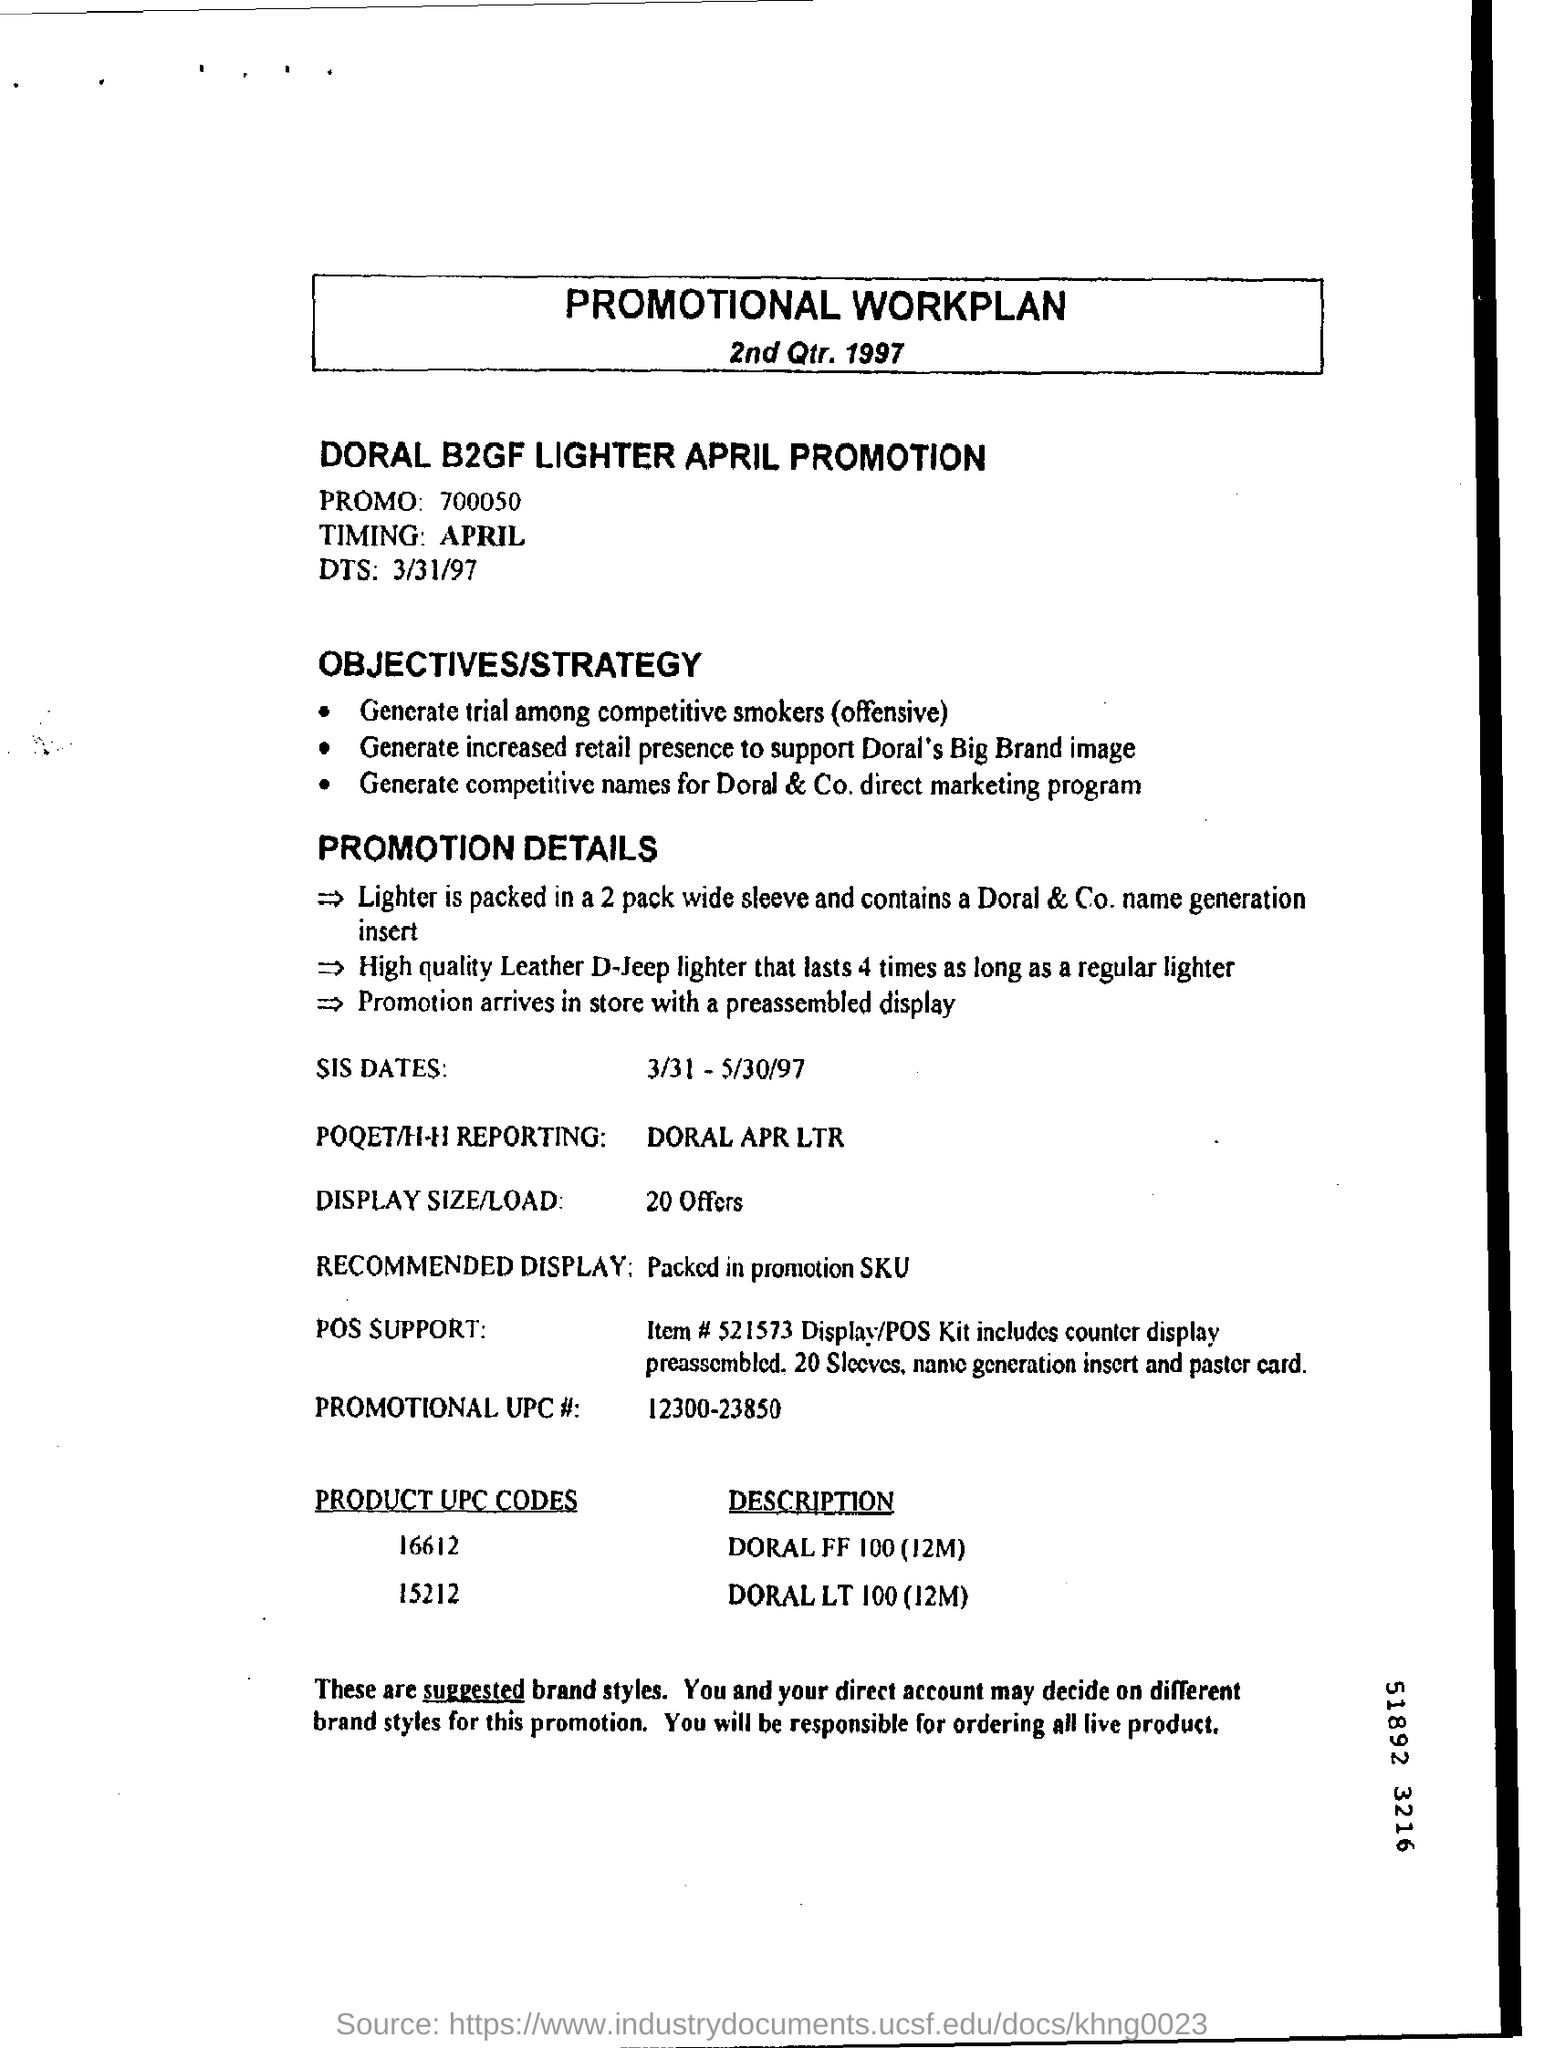Draw attention to some important aspects in this diagram. Display size and load are two factors that are important to consider when choosing a display for a particular application. These factors can have a significant impact on the overall performance and usability of the display, and it is important to carefully evaluate them before making a decision. The promo number is 700050. The title of the document is "Promotional Workplan. 